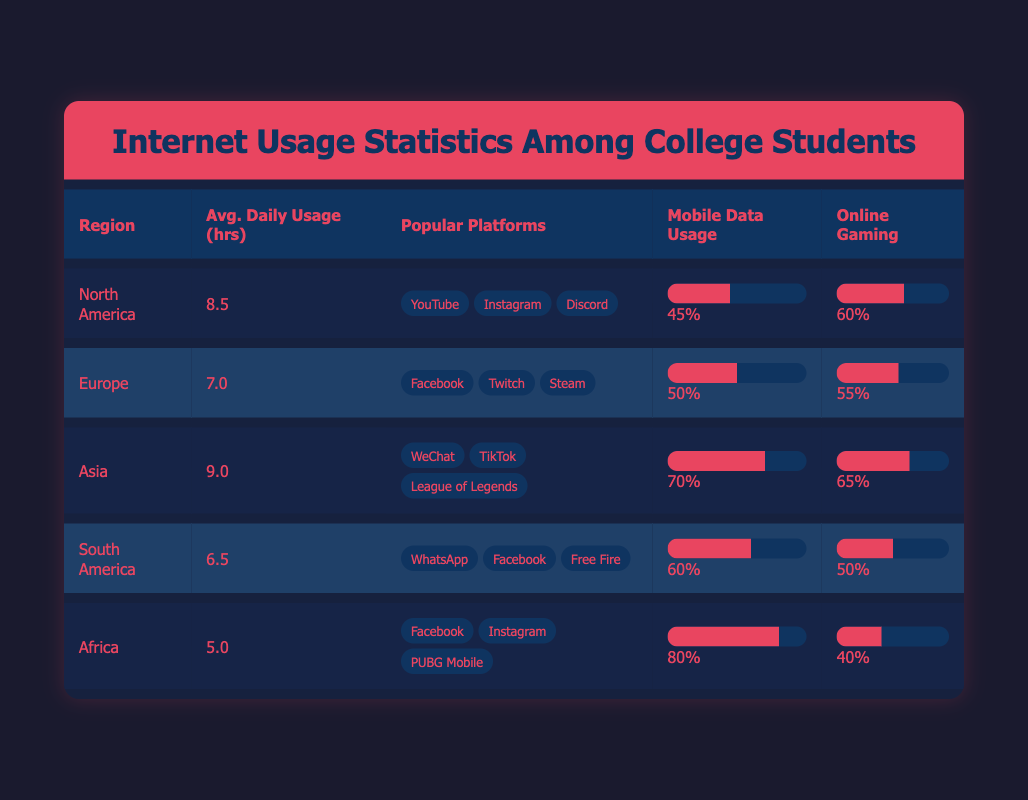What region has the highest average daily internet usage? According to the table, Asia has the highest average daily usage at 9.0 hours. This is greater than any of the other regions, where the average usage is lower (North America has 8.5, Europe has 7.0, South America has 6.5, and Africa has 5.0).
Answer: Asia Is the percentage of college students using mobile data in Africa higher than in Europe? The table indicates that 80% of college students in Africa use mobile data, while only 50% in Europe do. Therefore, the percentage in Africa is indeed higher than in Europe.
Answer: Yes What is the difference in average daily internet usage hours between North America and South America? The average daily internet usage in North America is 8.5 hours, while in South America it’s 6.5 hours. The difference can be calculated as 8.5 - 6.5 = 2.0 hours.
Answer: 2.0 Which region has the lowest percentage of students engaged in online gaming? The table shows that Africa has the lowest percentage of students engaged in online gaming at 40%, which is lower than all other regions: North America (60%), Europe (55%), Asia (65%), and South America (50%).
Answer: Africa What is the average percentage of mobile data usage among all regions? To find the average percentage of mobile data usage, we sum the percentages from each region: 45 + 50 + 70 + 60 + 80 = 305. Then, we divide by the number of regions (5): 305 / 5 = 61.0%.
Answer: 61.0 